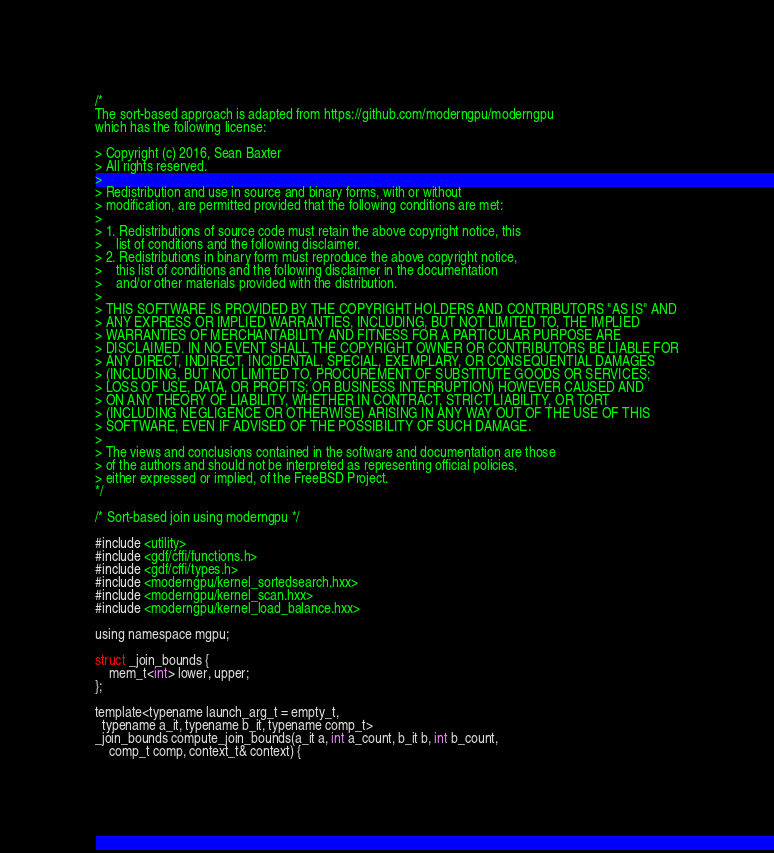<code> <loc_0><loc_0><loc_500><loc_500><_Cuda_>/*
The sort-based approach is adapted from https://github.com/moderngpu/moderngpu
which has the following license:

> Copyright (c) 2016, Sean Baxter
> All rights reserved.
>
> Redistribution and use in source and binary forms, with or without
> modification, are permitted provided that the following conditions are met:
>
> 1. Redistributions of source code must retain the above copyright notice, this
>    list of conditions and the following disclaimer.
> 2. Redistributions in binary form must reproduce the above copyright notice,
>    this list of conditions and the following disclaimer in the documentation
>    and/or other materials provided with the distribution.
>
> THIS SOFTWARE IS PROVIDED BY THE COPYRIGHT HOLDERS AND CONTRIBUTORS "AS IS" AND
> ANY EXPRESS OR IMPLIED WARRANTIES, INCLUDING, BUT NOT LIMITED TO, THE IMPLIED
> WARRANTIES OF MERCHANTABILITY AND FITNESS FOR A PARTICULAR PURPOSE ARE
> DISCLAIMED. IN NO EVENT SHALL THE COPYRIGHT OWNER OR CONTRIBUTORS BE LIABLE FOR
> ANY DIRECT, INDIRECT, INCIDENTAL, SPECIAL, EXEMPLARY, OR CONSEQUENTIAL DAMAGES
> (INCLUDING, BUT NOT LIMITED TO, PROCUREMENT OF SUBSTITUTE GOODS OR SERVICES;
> LOSS OF USE, DATA, OR PROFITS; OR BUSINESS INTERRUPTION) HOWEVER CAUSED AND
> ON ANY THEORY OF LIABILITY, WHETHER IN CONTRACT, STRICT LIABILITY, OR TORT
> (INCLUDING NEGLIGENCE OR OTHERWISE) ARISING IN ANY WAY OUT OF THE USE OF THIS
> SOFTWARE, EVEN IF ADVISED OF THE POSSIBILITY OF SUCH DAMAGE.
>
> The views and conclusions contained in the software and documentation are those
> of the authors and should not be interpreted as representing official policies,
> either expressed or implied, of the FreeBSD Project.
*/

/* Sort-based join using moderngpu */

#include <utility>
#include <gdf/cffi/functions.h>
#include <gdf/cffi/types.h>
#include <moderngpu/kernel_sortedsearch.hxx>
#include <moderngpu/kernel_scan.hxx>
#include <moderngpu/kernel_load_balance.hxx>

using namespace mgpu;

struct _join_bounds {
    mem_t<int> lower, upper;
};

template<typename launch_arg_t = empty_t,
  typename a_it, typename b_it, typename comp_t>
_join_bounds compute_join_bounds(a_it a, int a_count, b_it b, int b_count,
    comp_t comp, context_t& context) {
</code> 